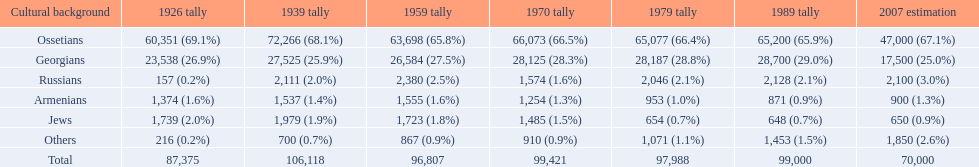How many ethnicity is there? 6. 